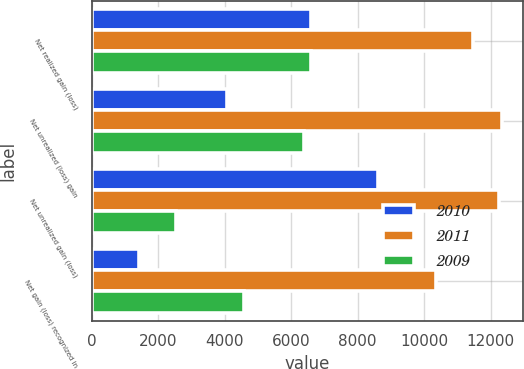<chart> <loc_0><loc_0><loc_500><loc_500><stacked_bar_chart><ecel><fcel>Net realized gain (loss)<fcel>Net unrealized (loss) gain<fcel>Net unrealized gain (loss)<fcel>Net gain (loss) recognized in<nl><fcel>2010<fcel>6604<fcel>4062<fcel>8606<fcel>1431<nl><fcel>2011<fcel>11470<fcel>12345<fcel>12247<fcel>10353<nl><fcel>2009<fcel>6604<fcel>6390<fcel>2535<fcel>4587<nl></chart> 